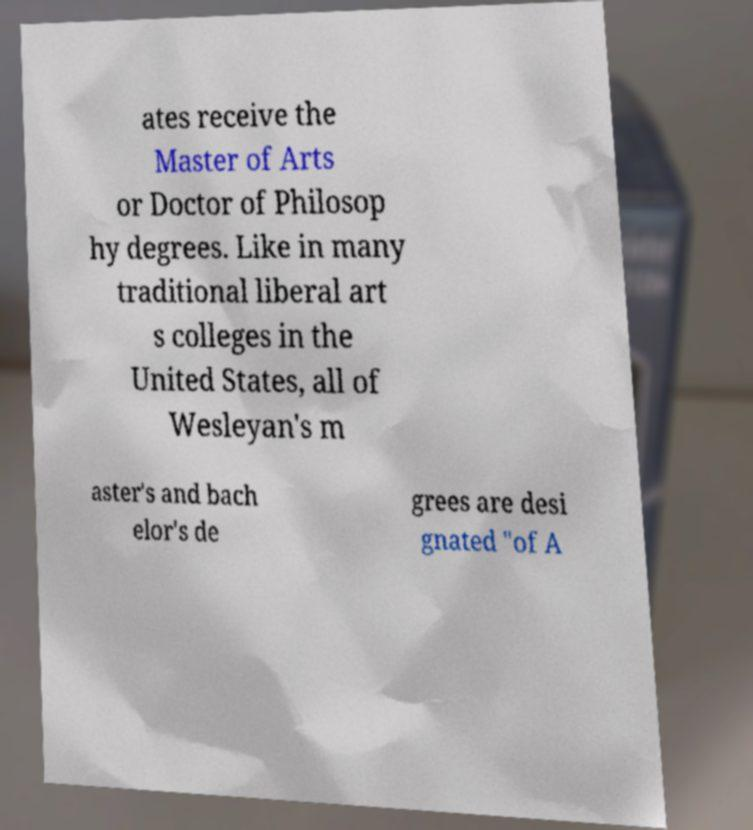There's text embedded in this image that I need extracted. Can you transcribe it verbatim? ates receive the Master of Arts or Doctor of Philosop hy degrees. Like in many traditional liberal art s colleges in the United States, all of Wesleyan's m aster's and bach elor's de grees are desi gnated "of A 